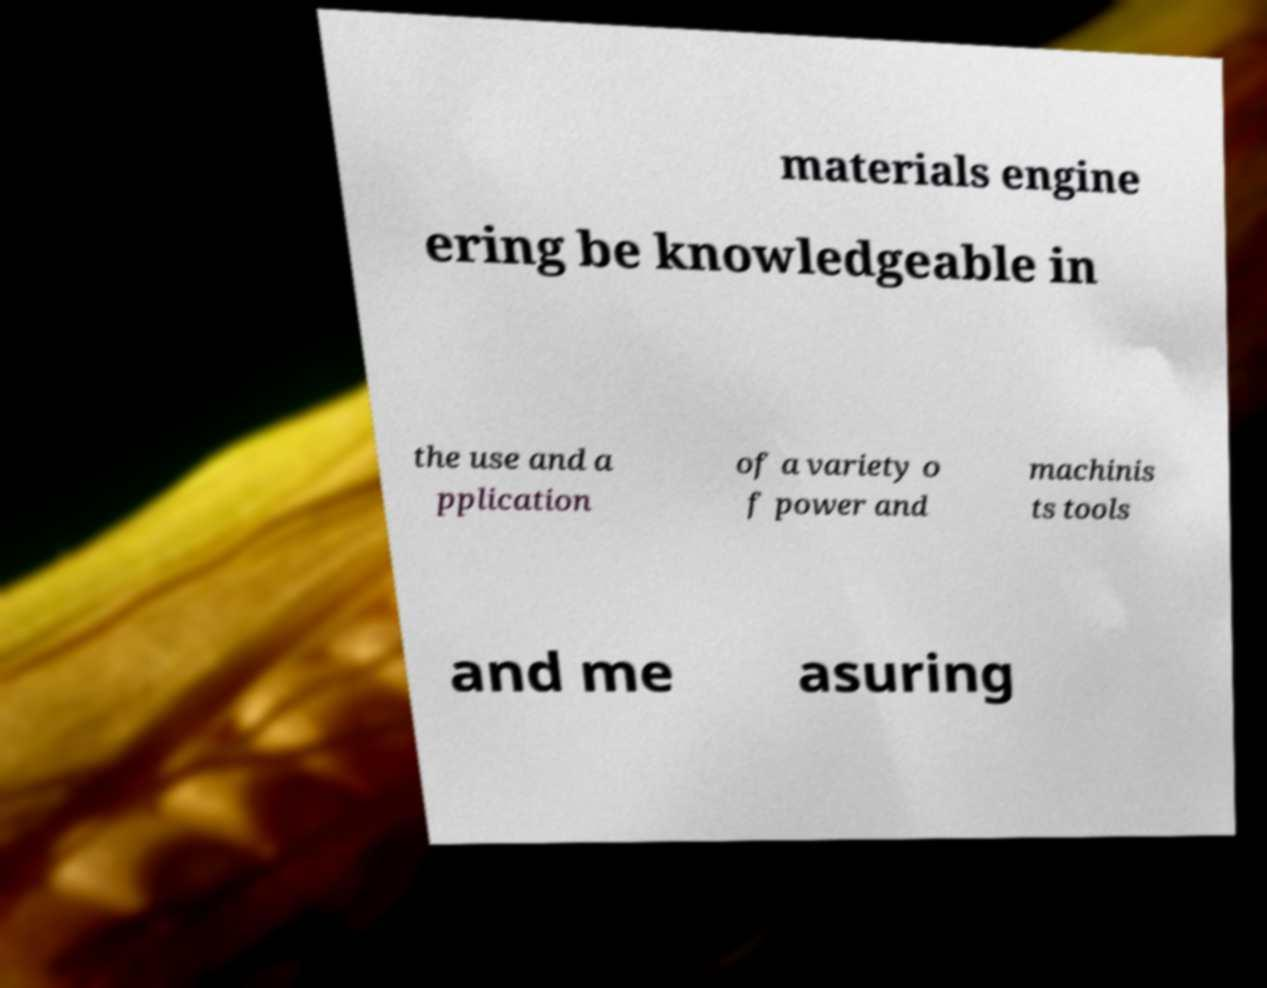For documentation purposes, I need the text within this image transcribed. Could you provide that? materials engine ering be knowledgeable in the use and a pplication of a variety o f power and machinis ts tools and me asuring 